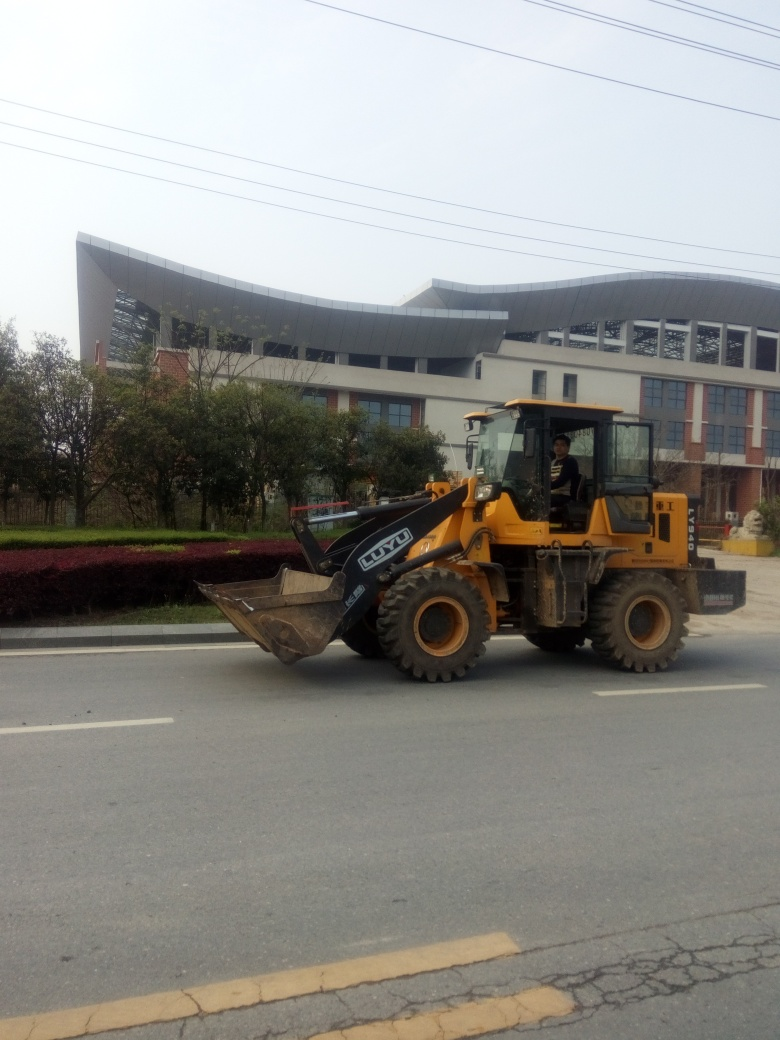Is the background clear?
A. Obstructed background
B. Relatively clear
C. Completely blurred background
Answer with the option's letter from the given choices directly.
 B. 